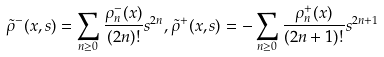Convert formula to latex. <formula><loc_0><loc_0><loc_500><loc_500>\tilde { \rho } ^ { - } ( x , s ) = \sum _ { n \geq 0 } \frac { \rho _ { n } ^ { - } ( x ) } { ( 2 n ) ! } s ^ { 2 n } , \tilde { \rho } ^ { + } ( x , s ) = - \sum _ { n \geq 0 } \frac { \rho _ { n } ^ { + } ( x ) } { ( 2 n + 1 ) ! } s ^ { 2 n + 1 }</formula> 